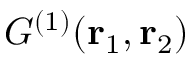<formula> <loc_0><loc_0><loc_500><loc_500>G ^ { ( 1 ) } ( { r } _ { 1 } , { r } _ { 2 } )</formula> 